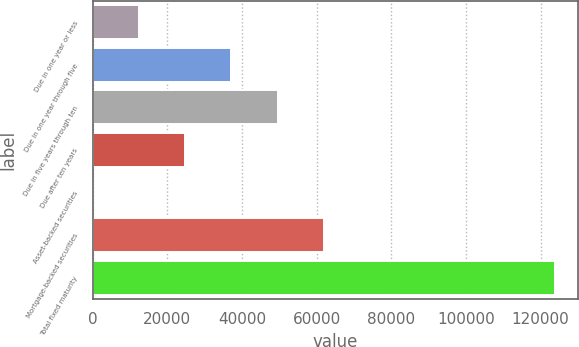Convert chart. <chart><loc_0><loc_0><loc_500><loc_500><bar_chart><fcel>Due in one year or less<fcel>Due in one year through five<fcel>Due in five years through ten<fcel>Due after ten years<fcel>Asset-backed securities<fcel>Mortgage-backed securities<fcel>Total fixed maturity<nl><fcel>12388.7<fcel>37154.1<fcel>49536.8<fcel>24771.4<fcel>6<fcel>61919.5<fcel>123833<nl></chart> 